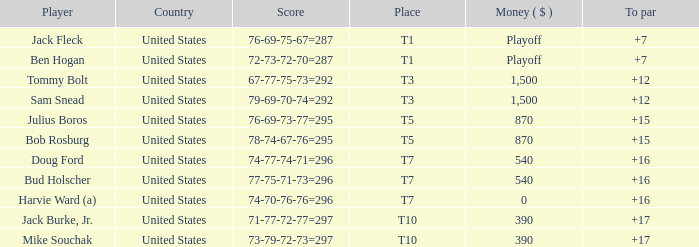What is average to par when Bud Holscher is the player? 16.0. 